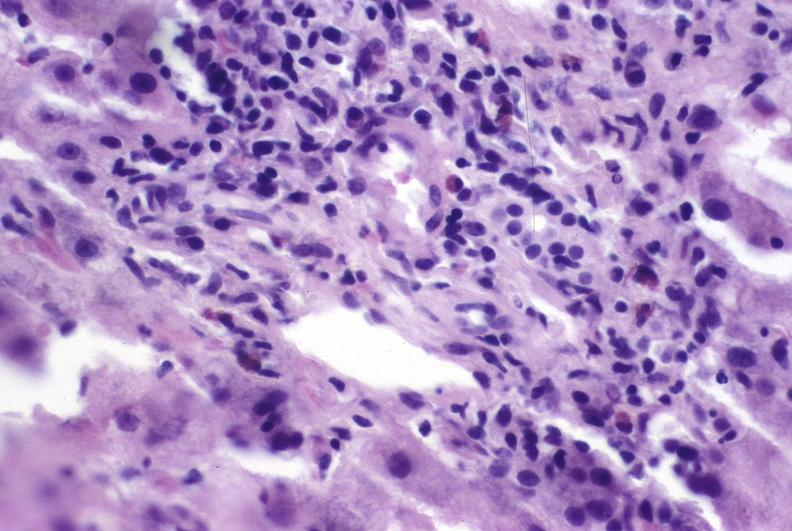s liver present?
Answer the question using a single word or phrase. Yes 